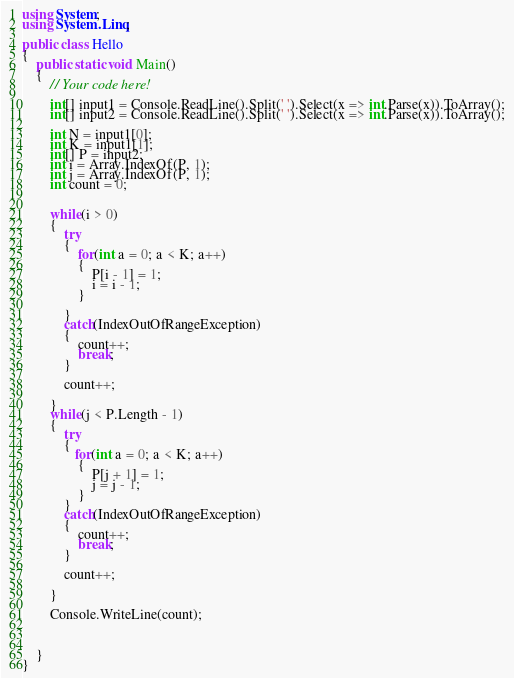<code> <loc_0><loc_0><loc_500><loc_500><_C#_>using System;
using System.Linq;

public class Hello
{
    public static void Main()
    {
        // Your code here!
        
        int[] input1 = Console.ReadLine().Split(' ').Select(x => int.Parse(x)).ToArray();
        int[] input2 = Console.ReadLine().Split(' ').Select(x => int.Parse(x)).ToArray();
        
        int N = input1[0];
        int K = input1[1];
        int[] P = input2;
        int i = Array.IndexOf(P, 1);
        int j = Array.IndexOf(P, 1);
        int count = 0;
        
       
        while(i > 0)
        {
            try
            {
                for(int a = 0; a < K; a++)
                {
                    P[i - 1] = 1;
                    i = i - 1;
                }
                
            }
            catch(IndexOutOfRangeException)
            {
                count++;
                break;
            }
            
            count++;
           
        }
        while(j < P.Length - 1)
        {
            try
            {
               for(int a = 0; a < K; a++)
                {
                    P[j + 1] = 1;
                    j = j - 1;
                }
            }
            catch(IndexOutOfRangeException)
            {
                count++;
                break;
            }
            
            count++;
           
        }
            
        Console.WriteLine(count);
        
       
        
    }
}</code> 